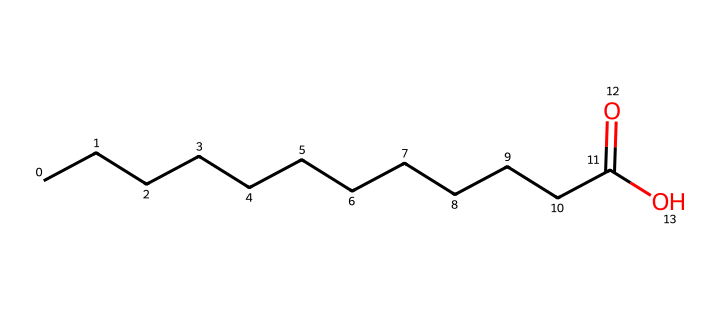What is the molecular formula of this compound? The SMILES notation "CCCCCCCCCCCC(=O)O" indicates the presence of 12 carbon (C) atoms, 24 hydrogen (H) atoms, and 2 oxygen (O) atoms. The absence of any other elements confirms this. Therefore, the molecular formula is C12H24O2.
Answer: C12H24O2 How many carbon atoms does this molecule contain? To find the number of carbon atoms, count the "C" symbols in the SMILES. The main chain indicates 12 carbon atoms before the functional groups, which remain consistent throughout.
Answer: 12 What type of functional group is present in this structure? The structure contains a carboxylic acid functional group, represented in the SMILES by "(=O)O" at the end of the chain, which indicates the presence of a carbon atom double-bonded to an oxygen atom and single-bonded to a hydroxyl group (-OH).
Answer: carboxylic acid Is this molecule saturated or unsaturated? The presence of only single bonds in the carbon chain (as derived from the SMILES notation) indicates that there are no double or triple bonds, classifying the compound as saturated.
Answer: saturated What is the total number of hydrogen atoms associated with this molecule? The hydrogen atoms are determined by the structure: for a saturated hydrocarbon, the general formula is CnH(2n+2). Here, n=12, giving us 2(12)+2=26. However, due to the carboxylic group, we actually have 24 hydrogen atoms.
Answer: 24 What determines the melting point and physical state of this substance? Coconut oil contains long-chain fatty acids, which usually have higher melting points due to stronger van der Waals forces among the hydrocarbon chains. The presence of the carboxylic acid also contributes to its stability.
Answer: strong intermolecular forces 